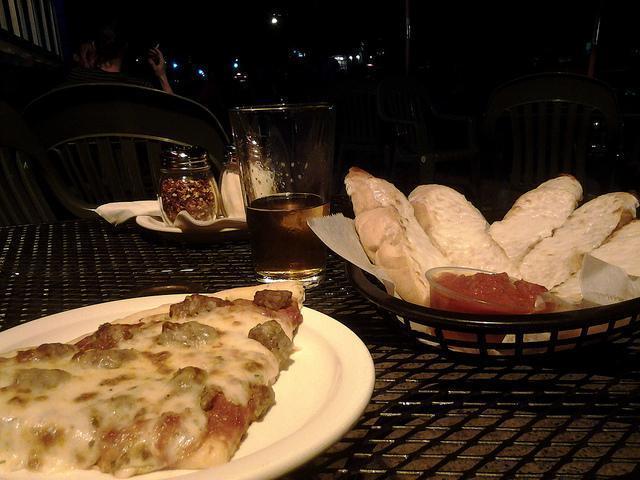How many slices of Pizza are on the table?
Give a very brief answer. 1. How many chairs are visible?
Give a very brief answer. 2. How many white horse do you see?
Give a very brief answer. 0. 